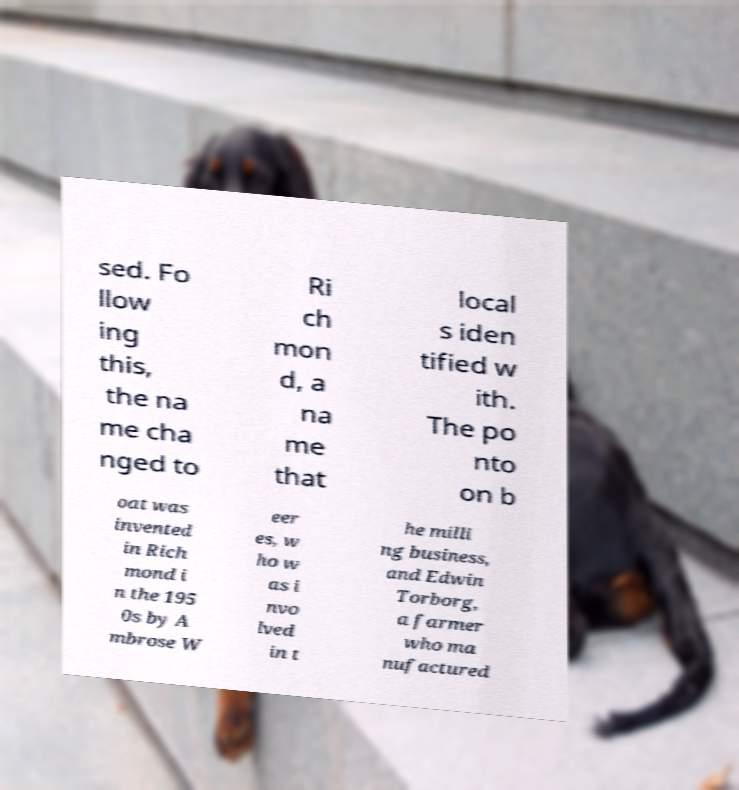Can you accurately transcribe the text from the provided image for me? sed. Fo llow ing this, the na me cha nged to Ri ch mon d, a na me that local s iden tified w ith. The po nto on b oat was invented in Rich mond i n the 195 0s by A mbrose W eer es, w ho w as i nvo lved in t he milli ng business, and Edwin Torborg, a farmer who ma nufactured 